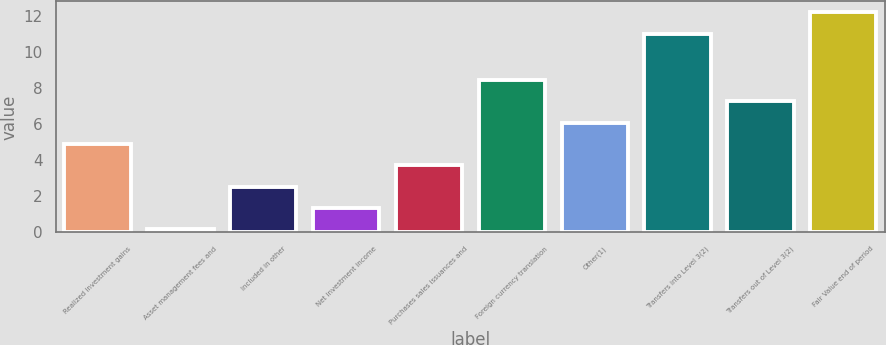Convert chart. <chart><loc_0><loc_0><loc_500><loc_500><bar_chart><fcel>Realized investment gains<fcel>Asset management fees and<fcel>Included in other<fcel>Net investment income<fcel>Purchases sales issuances and<fcel>Foreign currency translation<fcel>Other(1)<fcel>Transfers into Level 3(2)<fcel>Transfers out of Level 3(2)<fcel>Fair Value end of period<nl><fcel>4.89<fcel>0.17<fcel>2.53<fcel>1.35<fcel>3.71<fcel>8.43<fcel>6.07<fcel>11<fcel>7.25<fcel>12.18<nl></chart> 